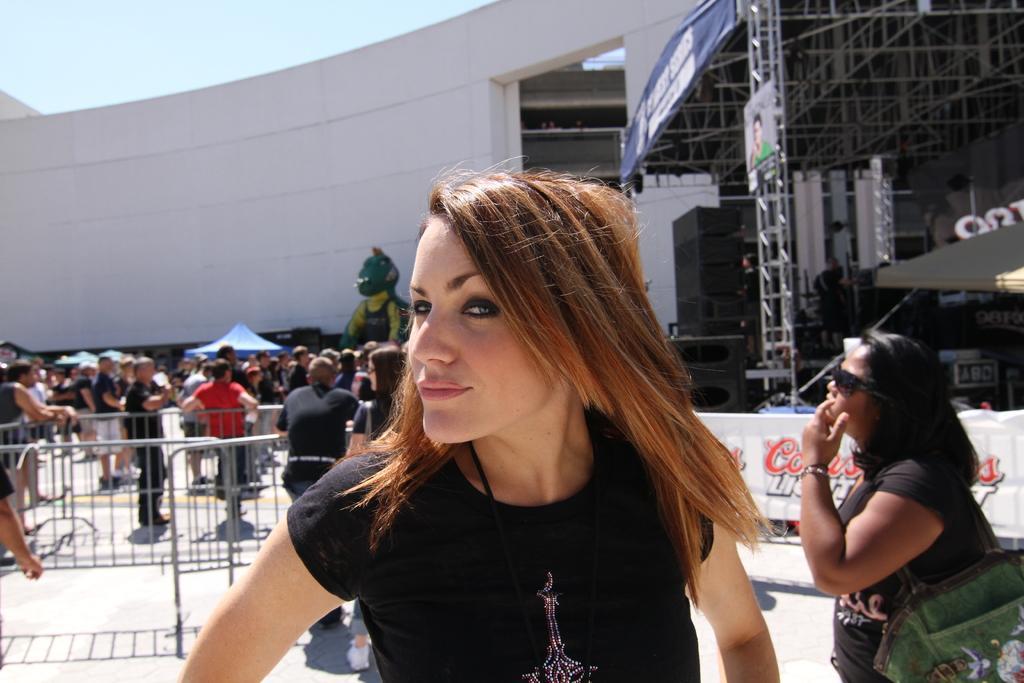Can you describe this image briefly? In the picture we can see a woman standing and smiling, she is wearing a black top, in the background we can see many people are standing and walking, and there is a railings near to there is a building wall and some steel construction shed with sound boxes and stage. 